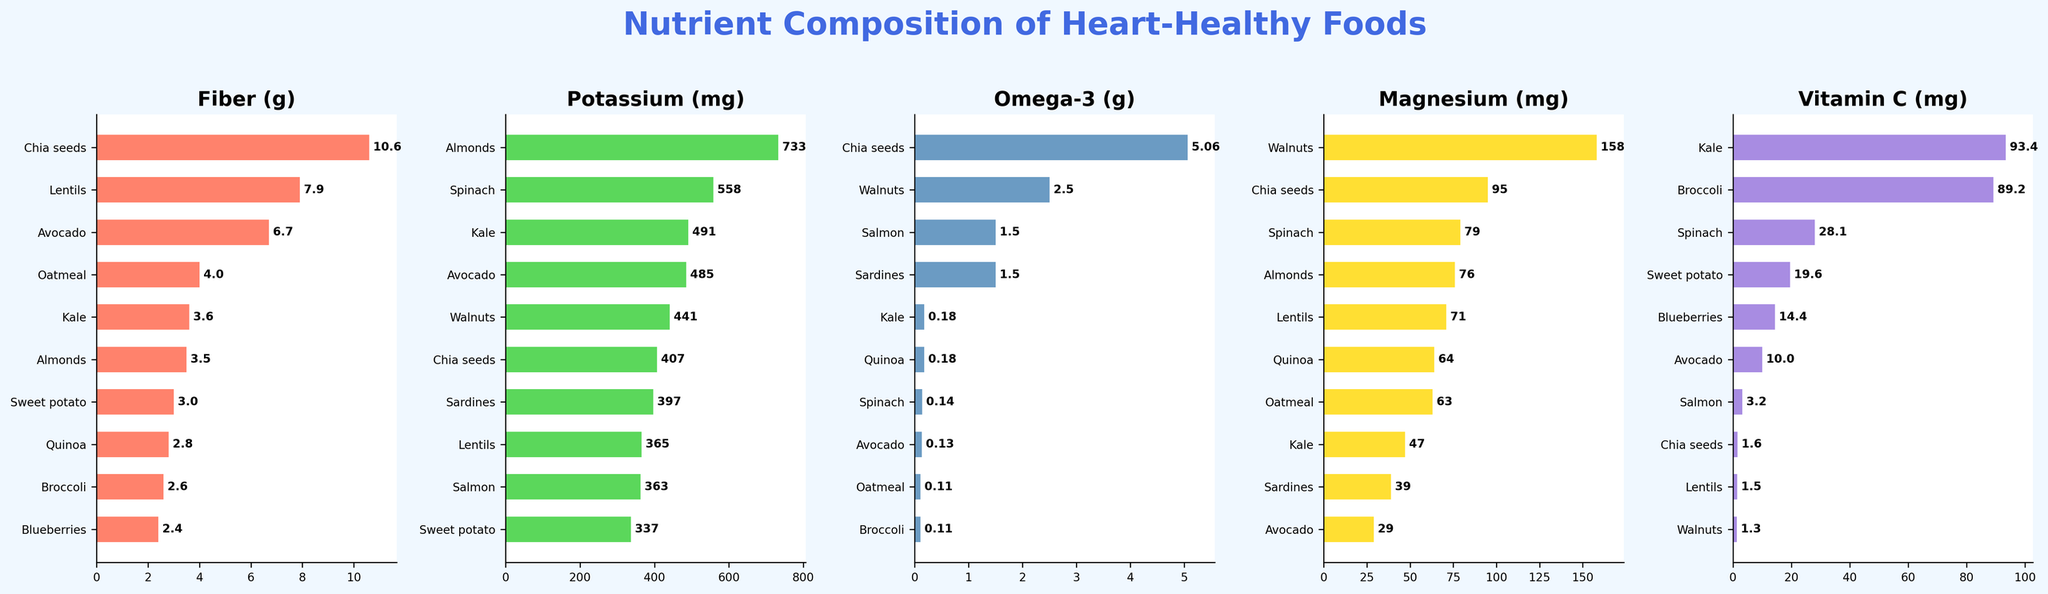Which food has the highest fiber content? Look at the "Fiber (g)" subplot and identify the food item with the longest bar. This is Chia seeds.
Answer: Chia seeds Which food offers the most vitamin C? Check the "Vitamin C (mg)" subplot and find the food with the longest bar, which is Kale.
Answer: Kale Compare the magnesium content of Almonds and Lentils. Which one is higher and by how much? Check the "Magnesium (mg)" subplot. Almonds have 76 mg and Lentils have 71 mg. The difference is 76 - 71 = 5 mg.
Answer: Almonds by 5 mg What's the combined potassium content of Spinach and Sweet potato? Look at the "Potassium (mg)" subplot. Spinach has 558 mg and Sweet potato has 337 mg. So, 558 + 337 = 895 mg.
Answer: 895 mg How does the omega-3 content of Walnuts compare to that of Salmon? Observe the "Omega-3 (g)" subplot. Walnuts have 2.5 g and Salmon has 1.5 g of omega-3. Walnuts have more by 1 g.
Answer: Walnuts by 1 g What's the average fiber content of Chia seeds, Lentils, and Oatmeal? On the "Fiber (g)" subplot, Chia seeds have 10.6 g, Lentils have 7.9 g, and Oatmeal has 4 g. The average is (10.6 + 7.9 + 4) / 3 = 7.5 g.
Answer: 7.5 g How many foods have a potassium content greater than 400 mg? Name them. Check the "Potassium (mg)" subplot. Salmon, Spinach, Almonds, Avocado, Lentils, Walnuts, Kale, and Sardines have more than 400 mg. There are 8 foods.
Answer: 8 foods: Salmon, Spinach, Almonds, Avocado, Lentils, Walnuts, Kale, and Sardines Find two foods with the closest magnesium content and state the difference. Look at the "Magnesium (mg)" subplot. Spinach has 79 mg and Almonds have 76 mg. Their difference is 3 mg.
Answer: Spinach and Almonds by 3 mg Which food has the lowest value in the "Vitamin C (mg)" subplot? Check the "Vitamin C (mg)" subplot, where Almonds, Greek yogurt, and Salmon have the smallest bar at 0 mg.
Answer: Almonds, Greek yogurt, and Salmon Identify the food with the highest sum of fiber and magnesium content. Add the values of fiber and magnesium for each food in the "Fiber (g)" and "Magnesium (mg)" subplots. For example, Chia seeds have 10.6+95=105.6 and it is the highest.
Answer: Chia seeds 